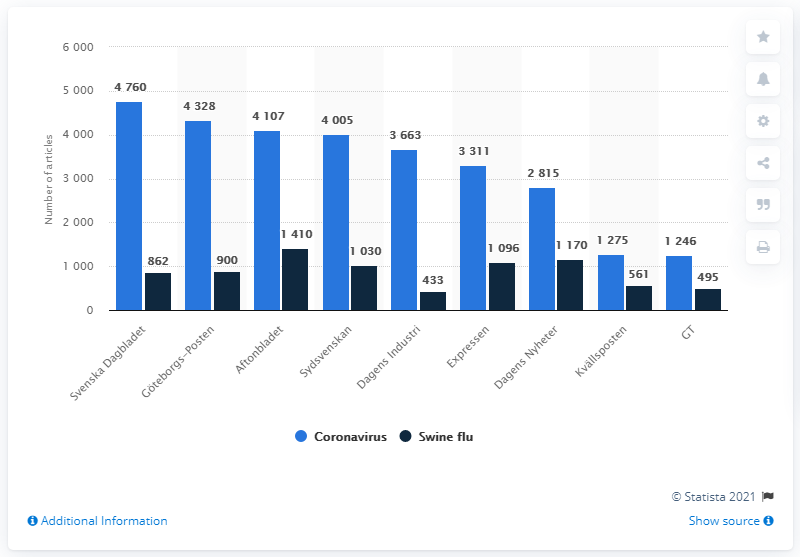Give some essential details in this illustration. The H1N1 influenza virus, commonly known as swine flu, was mentioned most prominently in the evening newspaper Aftonbladet. 